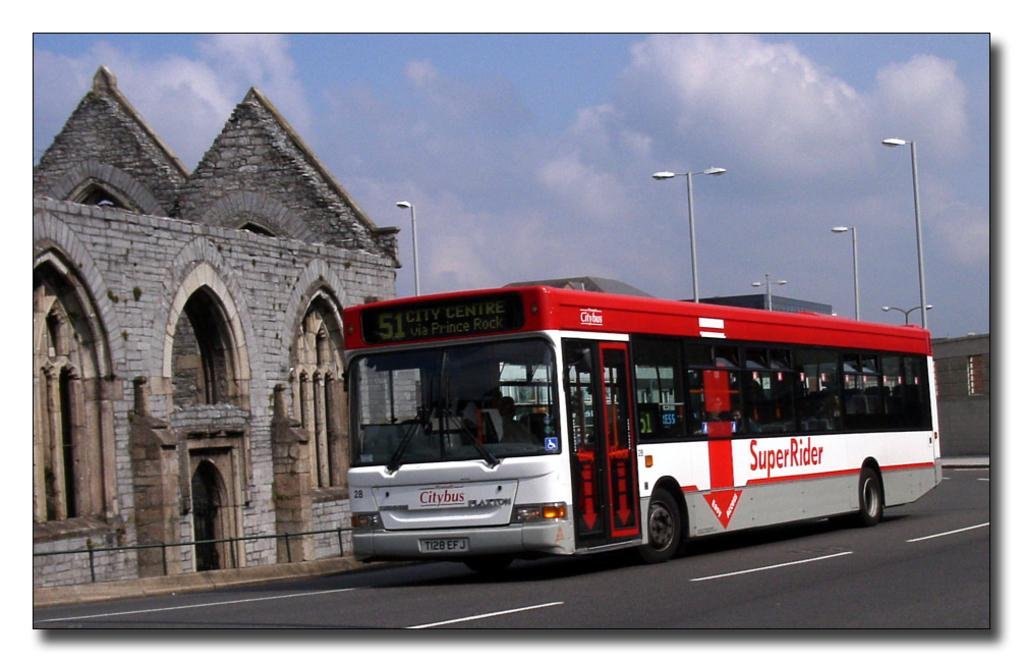What is moving on the road in the image? There is a bus moving on the road in the image. What can be seen illuminating the road in the image? There are street lights in the image. What type of structures are visible in the image? There are buildings in the image. What is visible in the background of the image? The sky is visible in the background of the image. What type of pie is being served on the bus in the image? There is no pie present in the image; it features a bus moving on the road with street lights, buildings, and the sky visible in the background. 